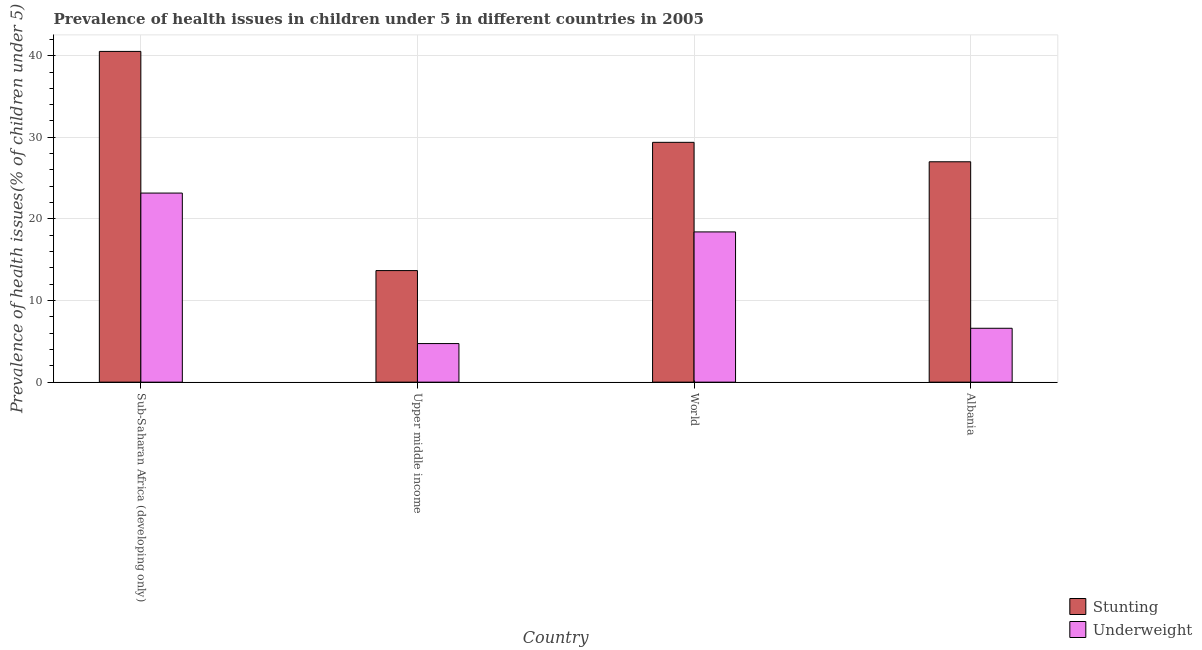How many groups of bars are there?
Your answer should be compact. 4. Are the number of bars per tick equal to the number of legend labels?
Ensure brevity in your answer.  Yes. Are the number of bars on each tick of the X-axis equal?
Make the answer very short. Yes. What is the label of the 4th group of bars from the left?
Provide a succinct answer. Albania. In how many cases, is the number of bars for a given country not equal to the number of legend labels?
Offer a terse response. 0. What is the percentage of stunted children in World?
Ensure brevity in your answer.  29.38. Across all countries, what is the maximum percentage of stunted children?
Give a very brief answer. 40.52. Across all countries, what is the minimum percentage of underweight children?
Offer a very short reply. 4.73. In which country was the percentage of stunted children maximum?
Give a very brief answer. Sub-Saharan Africa (developing only). In which country was the percentage of stunted children minimum?
Your response must be concise. Upper middle income. What is the total percentage of underweight children in the graph?
Keep it short and to the point. 52.9. What is the difference between the percentage of underweight children in Sub-Saharan Africa (developing only) and that in World?
Provide a succinct answer. 4.76. What is the difference between the percentage of stunted children in Upper middle income and the percentage of underweight children in Albania?
Provide a short and direct response. 7.07. What is the average percentage of underweight children per country?
Your response must be concise. 13.23. What is the difference between the percentage of underweight children and percentage of stunted children in Sub-Saharan Africa (developing only)?
Your answer should be compact. -17.36. In how many countries, is the percentage of stunted children greater than 26 %?
Keep it short and to the point. 3. What is the ratio of the percentage of stunted children in Sub-Saharan Africa (developing only) to that in Upper middle income?
Offer a very short reply. 2.96. Is the percentage of underweight children in Sub-Saharan Africa (developing only) less than that in Upper middle income?
Give a very brief answer. No. Is the difference between the percentage of stunted children in Albania and Upper middle income greater than the difference between the percentage of underweight children in Albania and Upper middle income?
Keep it short and to the point. Yes. What is the difference between the highest and the second highest percentage of stunted children?
Provide a short and direct response. 11.14. What is the difference between the highest and the lowest percentage of underweight children?
Provide a short and direct response. 18.44. In how many countries, is the percentage of stunted children greater than the average percentage of stunted children taken over all countries?
Your answer should be very brief. 2. What does the 2nd bar from the left in Albania represents?
Provide a short and direct response. Underweight. What does the 1st bar from the right in Sub-Saharan Africa (developing only) represents?
Ensure brevity in your answer.  Underweight. How many bars are there?
Provide a succinct answer. 8. Are all the bars in the graph horizontal?
Your response must be concise. No. How many countries are there in the graph?
Offer a terse response. 4. What is the difference between two consecutive major ticks on the Y-axis?
Offer a very short reply. 10. Does the graph contain any zero values?
Offer a terse response. No. How are the legend labels stacked?
Provide a short and direct response. Vertical. What is the title of the graph?
Your answer should be compact. Prevalence of health issues in children under 5 in different countries in 2005. Does "Quasi money growth" appear as one of the legend labels in the graph?
Ensure brevity in your answer.  No. What is the label or title of the Y-axis?
Your answer should be very brief. Prevalence of health issues(% of children under 5). What is the Prevalence of health issues(% of children under 5) in Stunting in Sub-Saharan Africa (developing only)?
Your answer should be compact. 40.52. What is the Prevalence of health issues(% of children under 5) in Underweight in Sub-Saharan Africa (developing only)?
Your answer should be compact. 23.17. What is the Prevalence of health issues(% of children under 5) of Stunting in Upper middle income?
Give a very brief answer. 13.67. What is the Prevalence of health issues(% of children under 5) in Underweight in Upper middle income?
Provide a short and direct response. 4.73. What is the Prevalence of health issues(% of children under 5) of Stunting in World?
Your response must be concise. 29.38. What is the Prevalence of health issues(% of children under 5) in Underweight in World?
Your answer should be compact. 18.41. What is the Prevalence of health issues(% of children under 5) of Underweight in Albania?
Ensure brevity in your answer.  6.6. Across all countries, what is the maximum Prevalence of health issues(% of children under 5) in Stunting?
Offer a terse response. 40.52. Across all countries, what is the maximum Prevalence of health issues(% of children under 5) in Underweight?
Provide a short and direct response. 23.17. Across all countries, what is the minimum Prevalence of health issues(% of children under 5) of Stunting?
Give a very brief answer. 13.67. Across all countries, what is the minimum Prevalence of health issues(% of children under 5) of Underweight?
Give a very brief answer. 4.73. What is the total Prevalence of health issues(% of children under 5) of Stunting in the graph?
Ensure brevity in your answer.  110.57. What is the total Prevalence of health issues(% of children under 5) in Underweight in the graph?
Your response must be concise. 52.9. What is the difference between the Prevalence of health issues(% of children under 5) of Stunting in Sub-Saharan Africa (developing only) and that in Upper middle income?
Make the answer very short. 26.85. What is the difference between the Prevalence of health issues(% of children under 5) of Underweight in Sub-Saharan Africa (developing only) and that in Upper middle income?
Give a very brief answer. 18.44. What is the difference between the Prevalence of health issues(% of children under 5) in Stunting in Sub-Saharan Africa (developing only) and that in World?
Provide a short and direct response. 11.14. What is the difference between the Prevalence of health issues(% of children under 5) of Underweight in Sub-Saharan Africa (developing only) and that in World?
Give a very brief answer. 4.76. What is the difference between the Prevalence of health issues(% of children under 5) in Stunting in Sub-Saharan Africa (developing only) and that in Albania?
Your answer should be very brief. 13.52. What is the difference between the Prevalence of health issues(% of children under 5) in Underweight in Sub-Saharan Africa (developing only) and that in Albania?
Your answer should be compact. 16.57. What is the difference between the Prevalence of health issues(% of children under 5) in Stunting in Upper middle income and that in World?
Provide a short and direct response. -15.71. What is the difference between the Prevalence of health issues(% of children under 5) of Underweight in Upper middle income and that in World?
Keep it short and to the point. -13.68. What is the difference between the Prevalence of health issues(% of children under 5) of Stunting in Upper middle income and that in Albania?
Ensure brevity in your answer.  -13.33. What is the difference between the Prevalence of health issues(% of children under 5) of Underweight in Upper middle income and that in Albania?
Make the answer very short. -1.87. What is the difference between the Prevalence of health issues(% of children under 5) in Stunting in World and that in Albania?
Your answer should be very brief. 2.38. What is the difference between the Prevalence of health issues(% of children under 5) in Underweight in World and that in Albania?
Offer a very short reply. 11.81. What is the difference between the Prevalence of health issues(% of children under 5) in Stunting in Sub-Saharan Africa (developing only) and the Prevalence of health issues(% of children under 5) in Underweight in Upper middle income?
Give a very brief answer. 35.8. What is the difference between the Prevalence of health issues(% of children under 5) of Stunting in Sub-Saharan Africa (developing only) and the Prevalence of health issues(% of children under 5) of Underweight in World?
Your answer should be compact. 22.11. What is the difference between the Prevalence of health issues(% of children under 5) in Stunting in Sub-Saharan Africa (developing only) and the Prevalence of health issues(% of children under 5) in Underweight in Albania?
Give a very brief answer. 33.92. What is the difference between the Prevalence of health issues(% of children under 5) in Stunting in Upper middle income and the Prevalence of health issues(% of children under 5) in Underweight in World?
Keep it short and to the point. -4.74. What is the difference between the Prevalence of health issues(% of children under 5) in Stunting in Upper middle income and the Prevalence of health issues(% of children under 5) in Underweight in Albania?
Make the answer very short. 7.07. What is the difference between the Prevalence of health issues(% of children under 5) in Stunting in World and the Prevalence of health issues(% of children under 5) in Underweight in Albania?
Give a very brief answer. 22.78. What is the average Prevalence of health issues(% of children under 5) of Stunting per country?
Give a very brief answer. 27.64. What is the average Prevalence of health issues(% of children under 5) of Underweight per country?
Your answer should be compact. 13.23. What is the difference between the Prevalence of health issues(% of children under 5) in Stunting and Prevalence of health issues(% of children under 5) in Underweight in Sub-Saharan Africa (developing only)?
Provide a short and direct response. 17.36. What is the difference between the Prevalence of health issues(% of children under 5) of Stunting and Prevalence of health issues(% of children under 5) of Underweight in Upper middle income?
Offer a terse response. 8.94. What is the difference between the Prevalence of health issues(% of children under 5) of Stunting and Prevalence of health issues(% of children under 5) of Underweight in World?
Offer a terse response. 10.97. What is the difference between the Prevalence of health issues(% of children under 5) in Stunting and Prevalence of health issues(% of children under 5) in Underweight in Albania?
Provide a short and direct response. 20.4. What is the ratio of the Prevalence of health issues(% of children under 5) in Stunting in Sub-Saharan Africa (developing only) to that in Upper middle income?
Your answer should be compact. 2.96. What is the ratio of the Prevalence of health issues(% of children under 5) of Underweight in Sub-Saharan Africa (developing only) to that in Upper middle income?
Provide a succinct answer. 4.9. What is the ratio of the Prevalence of health issues(% of children under 5) in Stunting in Sub-Saharan Africa (developing only) to that in World?
Your answer should be very brief. 1.38. What is the ratio of the Prevalence of health issues(% of children under 5) of Underweight in Sub-Saharan Africa (developing only) to that in World?
Your answer should be compact. 1.26. What is the ratio of the Prevalence of health issues(% of children under 5) in Stunting in Sub-Saharan Africa (developing only) to that in Albania?
Ensure brevity in your answer.  1.5. What is the ratio of the Prevalence of health issues(% of children under 5) in Underweight in Sub-Saharan Africa (developing only) to that in Albania?
Offer a terse response. 3.51. What is the ratio of the Prevalence of health issues(% of children under 5) in Stunting in Upper middle income to that in World?
Your answer should be very brief. 0.47. What is the ratio of the Prevalence of health issues(% of children under 5) in Underweight in Upper middle income to that in World?
Your answer should be compact. 0.26. What is the ratio of the Prevalence of health issues(% of children under 5) in Stunting in Upper middle income to that in Albania?
Your answer should be very brief. 0.51. What is the ratio of the Prevalence of health issues(% of children under 5) of Underweight in Upper middle income to that in Albania?
Give a very brief answer. 0.72. What is the ratio of the Prevalence of health issues(% of children under 5) in Stunting in World to that in Albania?
Provide a short and direct response. 1.09. What is the ratio of the Prevalence of health issues(% of children under 5) of Underweight in World to that in Albania?
Offer a terse response. 2.79. What is the difference between the highest and the second highest Prevalence of health issues(% of children under 5) in Stunting?
Provide a short and direct response. 11.14. What is the difference between the highest and the second highest Prevalence of health issues(% of children under 5) in Underweight?
Keep it short and to the point. 4.76. What is the difference between the highest and the lowest Prevalence of health issues(% of children under 5) of Stunting?
Offer a very short reply. 26.85. What is the difference between the highest and the lowest Prevalence of health issues(% of children under 5) of Underweight?
Offer a terse response. 18.44. 